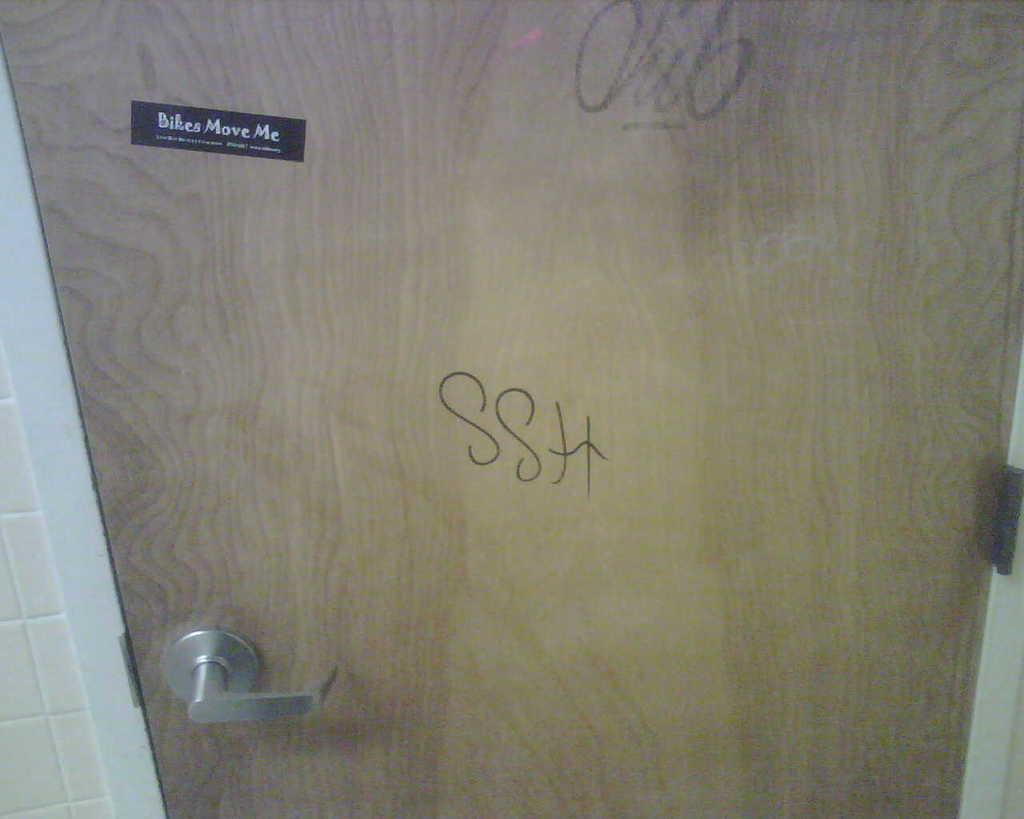What type of structure can be seen in the image? There is a wall in the image. What feature is present on the wall in the image? There is a door with a handle in the image. Is there any additional detail on the door? Yes, there is a sticker on the door and some text. What is the price of the beggar in the image? There is no beggar present in the image, and therefore no price can be determined. What effect does the sticker have on the door in the image? The provided facts do not mention any effect the sticker has on the door, so we cannot determine its impact. 